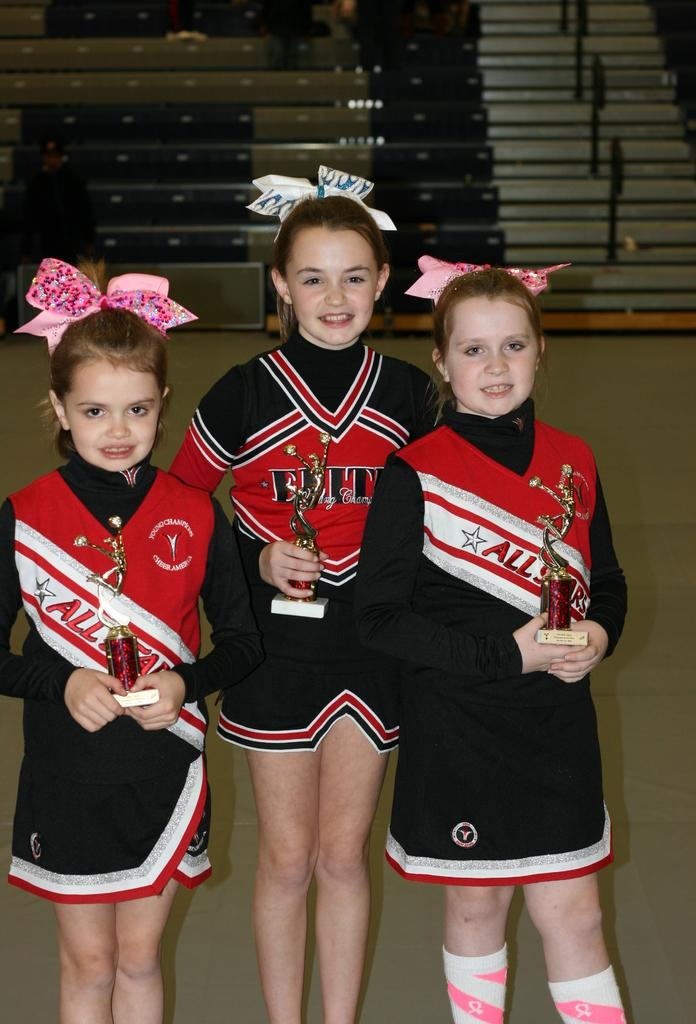<image>
Write a terse but informative summary of the picture. three kids that are wearing all star jerseys that are red and white 